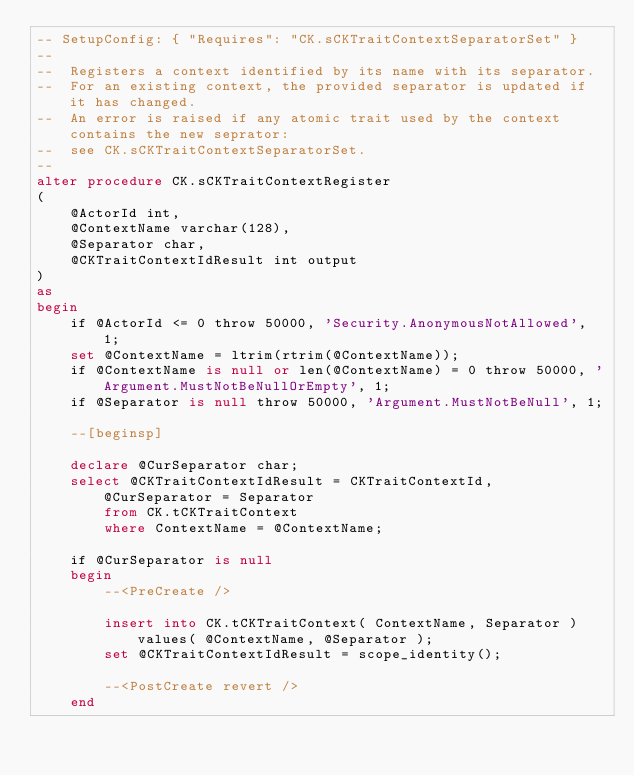Convert code to text. <code><loc_0><loc_0><loc_500><loc_500><_SQL_>-- SetupConfig: { "Requires": "CK.sCKTraitContextSeparatorSet" }
--
--	Registers a context identified by its name with its separator.
--  For an existing context, the provided separator is updated if it has changed.
--  An error is raised if any atomic trait used by the context contains the new seprator:
--  see CK.sCKTraitContextSeparatorSet. 
--
alter procedure CK.sCKTraitContextRegister
(
	@ActorId int,
	@ContextName varchar(128),
	@Separator char,
	@CKTraitContextIdResult int output
)
as
begin
    if @ActorId <= 0 throw 50000, 'Security.AnonymousNotAllowed', 1;
    set @ContextName = ltrim(rtrim(@ContextName));
    if @ContextName is null or len(@ContextName) = 0 throw 50000, 'Argument.MustNotBeNullOrEmpty', 1;
    if @Separator is null throw 50000, 'Argument.MustNotBeNull', 1;

	--[beginsp]

	declare @CurSeparator char;
	select @CKTraitContextIdResult = CKTraitContextId, @CurSeparator = Separator
		from CK.tCKTraitContext
		where ContextName = @ContextName;

	if @CurSeparator is null
	begin
		--<PreCreate /> 

		insert into CK.tCKTraitContext( ContextName, Separator ) values( @ContextName, @Separator );
  		set @CKTraitContextIdResult = scope_identity();

		--<PostCreate revert /> 
	end</code> 